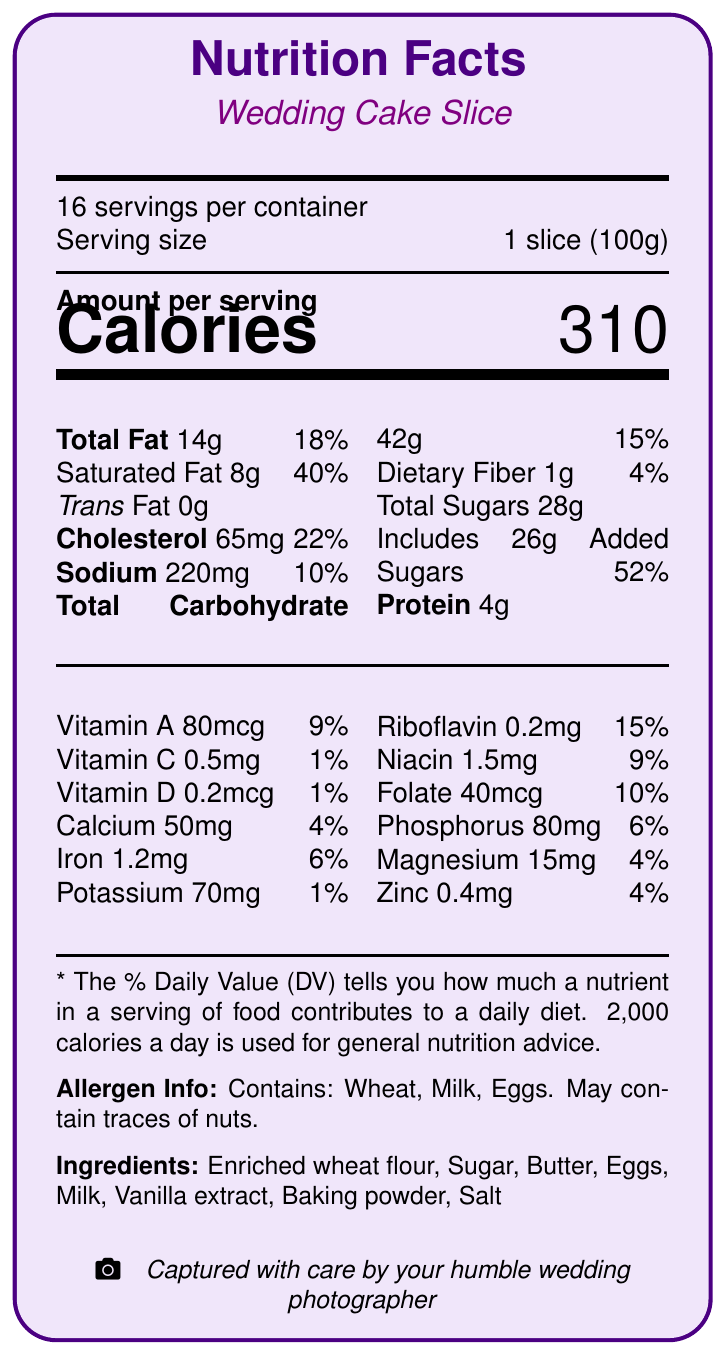What is the serving size for the wedding cake slice? The document specifies that the serving size is 1 slice (100g).
Answer: 1 slice (100g) How many servings are there in a container? The document mentions that there are 16 servings per container.
Answer: 16 What is the total fat content in a serving of the cake? The document shows that the cake contains 14g of total fat per serving.
Answer: 14g What percentage of the daily value of saturated fat does one slice of the cake contain? The document lists that one slice contains 8g of saturated fat, which is 40% of the daily value.
Answer: 40% How many grams of added sugars are in one serving of the cake? The document states that there are 26g of added sugars in each serving.
Answer: 26g What allergens are present in the wedding cake? The allergen information section of the document indicates the cake contains wheat, milk, and eggs.
Answer: Wheat, Milk, Eggs What is the total carbohydrate content in one serving? The document specifies that the total carbohydrate content in one serving is 42g.
Answer: 42g Which vitamin has the highest daily value percentage in the cake? A. Vitamin A B. Vitamin B2 (Riboflavin) C. Calcium D. Iron The document shows Riboflavin has the highest DV percentage at 15%.
Answer: B What is the amount of protein in one slice of cake? The document mentions that there are 4g of protein per serving.
Answer: 4g Does the cake contain trans fat? The document states that the cake has 0g of trans fat.
Answer: No How many calories are in one serving of the wedding cake? The document indicates that each serving has 310 calories.
Answer: 310 Which ingredient is not listed in the cake ingredients? A. Sugar B. Butter C. Cream D. Enriched wheat flour The ingredient list does not include cream.
Answer: C What portion of the daily value of sodium does one slice of cake contribute? The document lists 220mg of sodium per serving, which is 10% of the daily value.
Answer: 10% How much Vitamin D is present in one serving? The document states that one serving contains 0.2mcg of Vitamin D.
Answer: 0.2mcg Is the wedding cake suitable for someone with a nut allergy? The allergen info mentions that the cake contains wheat, milk, and eggs, and may contain traces of nuts, so it may not be suitable for someone with a nut allergy.
Answer: Maybe Summarize the nutritional information provided for the wedding cake slice The document comprehensively lists out the nutritional content per serving of the cake, the daily values, the ingredients present in the cake, and the allergens which could affect some individuals.
Answer: The document provides detailed nutritional information for a wedding cake slice, including the serving size, servings per container, calorie count, and percentages of daily values for various nutrients. It also lists the ingredients and allergen information. What is the main type of fat in the wedding cake slice and its daily value percentage? The document states that the cake slice has 8g of saturated fat, which is 40% of the daily value.
Answer: Saturated Fat, 40% How many mcg of folate are in one slice of the cake? The document mentions that there are 40mcg of folate per serving.
Answer: 40mcg What is the appearance of the wedding cake as described in the photographer notes? The photographer notes describe the cake’s appearance as an elegant three-tier white fondant cake with delicate sugar flowers.
Answer: Elegant three-tier white fondant cake with delicate sugar flowers How much riboflavin is in one serving of the cake? The document indicates that there are 0.2mg of riboflavin per serving.
Answer: 0.2mg How should the lighting be used when photographing the cake? The photographer's notes recommend using soft, diffused lighting to capture the cake’s texture without harsh shadows.
Answer: Use soft, diffused lighting to capture the cake's texture without harsh shadows What is the potassium content in one slice of the wedding cake? The document states that the potassium content per serving is 70mg.
Answer: 70mg Why is it important for a photographer to be aware of the nutritional information of the cake? The photographer's notes indicate that understanding nutritional information helps when discussing dietary restrictions with clients.
Answer: To be aware of dietary restrictions and offer alternatives when discussing cake options with clients. 